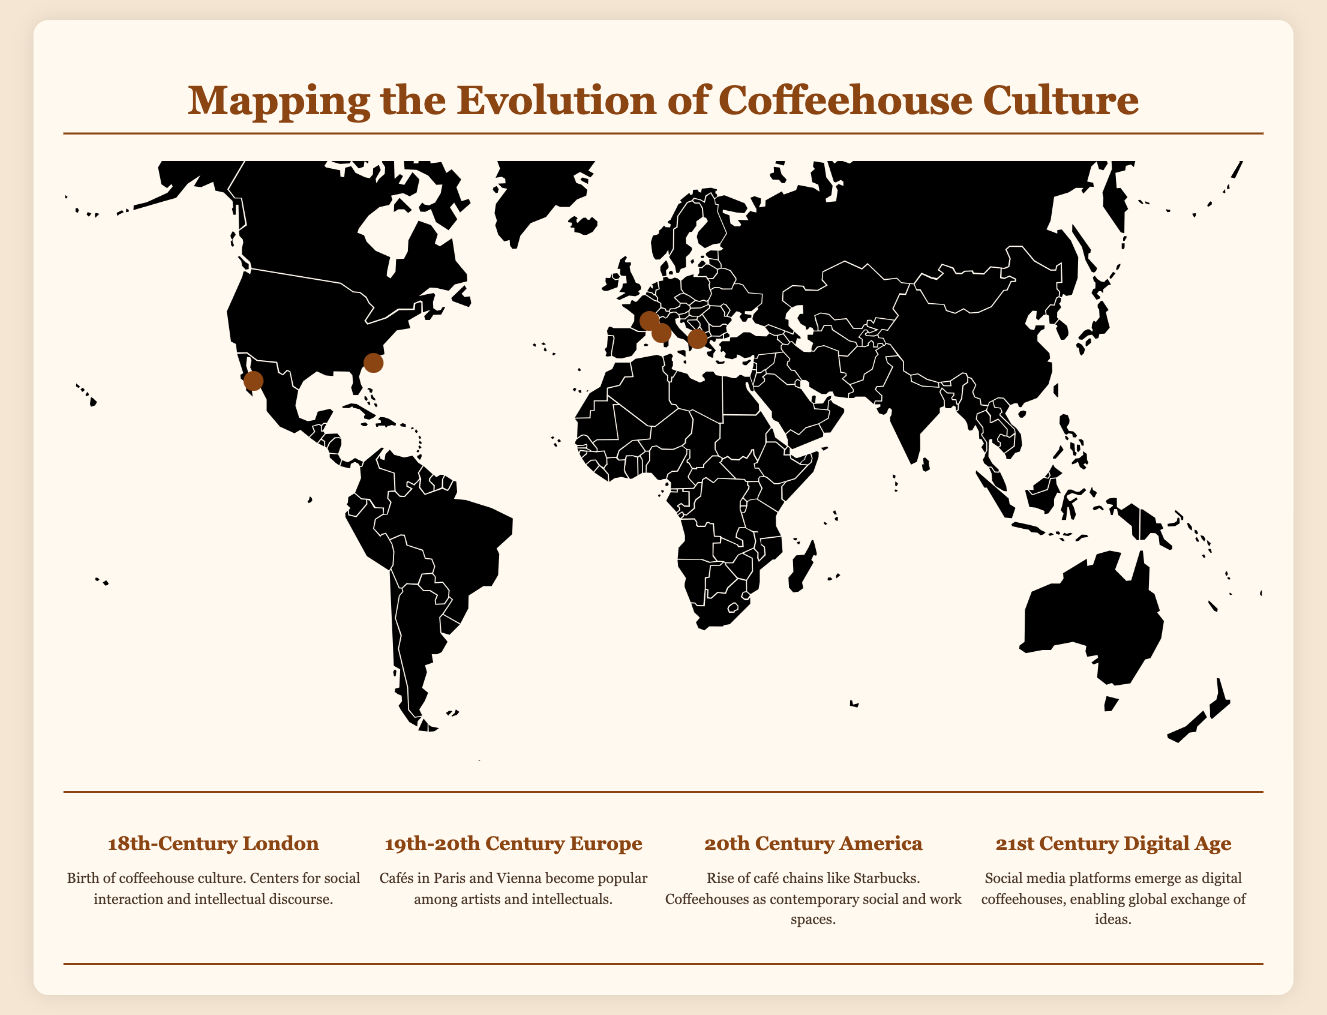What city is marked for 18th-century coffeehouse culture? The document highlights London as the focus of coffeehouse culture in the 18th century.
Answer: London What was the purpose of coffeehouses in 18th-century London? Coffeehouses served as centers for social interaction and intellectual discourse during this era.
Answer: Social interaction and intellectual discourse Which city is associated with cafés popular among artists in the 19th-20th century? The document indicates that Paris and Vienna saw the rise of cafés frequented by artists and intellectuals.
Answer: Paris and Vienna What is the significance of Starbucks in the 20th Century America section? The text mentions that Starbucks represents the rise of café chains during this period.
Answer: Rise of café chains What are modern social media platforms compared to in the 21st century? The document likens social media platforms to digital coffeehouses that facilitate a global exchange of ideas.
Answer: Digital coffeehouses How many eras are discussed in the timeline? The timeline presents four distinct eras related to the evolution of coffeehouse culture.
Answer: Four eras Which city appears at the top left of the map? The location of New York is indicated at the top left of the map.
Answer: New York What color are the markers for each location on the map? The markers, indicating each coffeehouse culture location, are colored brown.
Answer: Brown 